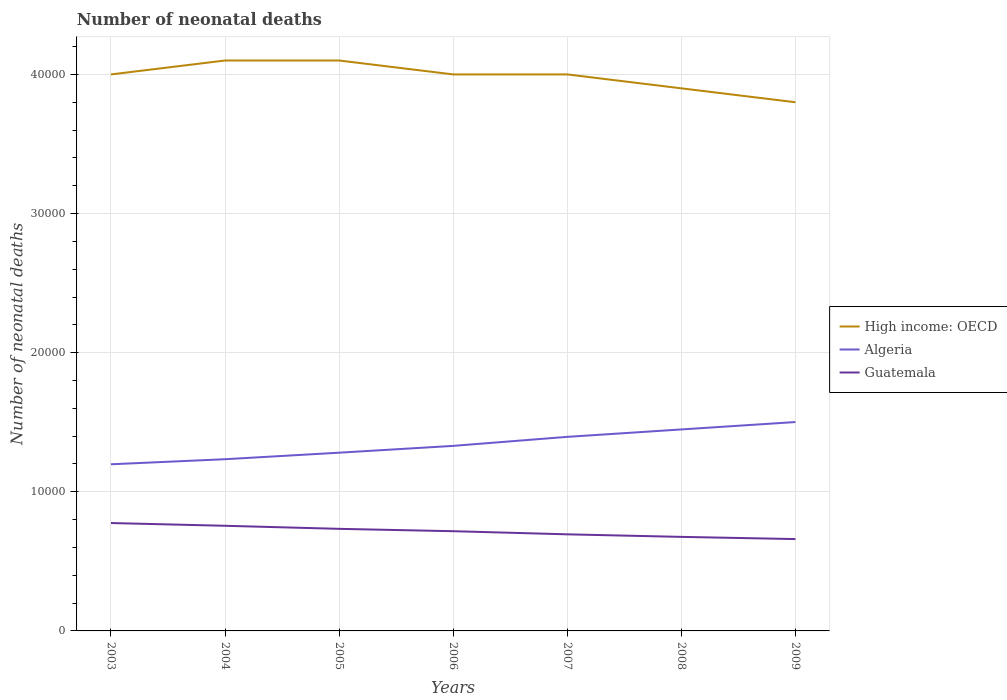How many different coloured lines are there?
Provide a succinct answer. 3. Does the line corresponding to Guatemala intersect with the line corresponding to Algeria?
Provide a short and direct response. No. Across all years, what is the maximum number of neonatal deaths in in High income: OECD?
Your answer should be very brief. 3.80e+04. What is the total number of neonatal deaths in in Algeria in the graph?
Your response must be concise. -1138. What is the difference between the highest and the second highest number of neonatal deaths in in Algeria?
Give a very brief answer. 3035. What is the difference between two consecutive major ticks on the Y-axis?
Your answer should be very brief. 10000. Are the values on the major ticks of Y-axis written in scientific E-notation?
Keep it short and to the point. No. Does the graph contain any zero values?
Provide a succinct answer. No. How many legend labels are there?
Your answer should be very brief. 3. How are the legend labels stacked?
Make the answer very short. Vertical. What is the title of the graph?
Your response must be concise. Number of neonatal deaths. Does "Mozambique" appear as one of the legend labels in the graph?
Offer a terse response. No. What is the label or title of the X-axis?
Offer a very short reply. Years. What is the label or title of the Y-axis?
Keep it short and to the point. Number of neonatal deaths. What is the Number of neonatal deaths in High income: OECD in 2003?
Your answer should be compact. 4.00e+04. What is the Number of neonatal deaths of Algeria in 2003?
Offer a very short reply. 1.20e+04. What is the Number of neonatal deaths of Guatemala in 2003?
Provide a short and direct response. 7755. What is the Number of neonatal deaths of High income: OECD in 2004?
Offer a terse response. 4.10e+04. What is the Number of neonatal deaths in Algeria in 2004?
Offer a terse response. 1.23e+04. What is the Number of neonatal deaths of Guatemala in 2004?
Provide a short and direct response. 7557. What is the Number of neonatal deaths of High income: OECD in 2005?
Provide a succinct answer. 4.10e+04. What is the Number of neonatal deaths of Algeria in 2005?
Your answer should be very brief. 1.28e+04. What is the Number of neonatal deaths of Guatemala in 2005?
Your response must be concise. 7337. What is the Number of neonatal deaths in Algeria in 2006?
Provide a short and direct response. 1.33e+04. What is the Number of neonatal deaths of Guatemala in 2006?
Keep it short and to the point. 7168. What is the Number of neonatal deaths of High income: OECD in 2007?
Your response must be concise. 4.00e+04. What is the Number of neonatal deaths of Algeria in 2007?
Your answer should be very brief. 1.39e+04. What is the Number of neonatal deaths of Guatemala in 2007?
Keep it short and to the point. 6943. What is the Number of neonatal deaths in High income: OECD in 2008?
Provide a short and direct response. 3.90e+04. What is the Number of neonatal deaths in Algeria in 2008?
Ensure brevity in your answer.  1.45e+04. What is the Number of neonatal deaths in Guatemala in 2008?
Your answer should be compact. 6760. What is the Number of neonatal deaths of High income: OECD in 2009?
Offer a very short reply. 3.80e+04. What is the Number of neonatal deaths of Algeria in 2009?
Provide a short and direct response. 1.50e+04. What is the Number of neonatal deaths in Guatemala in 2009?
Your response must be concise. 6601. Across all years, what is the maximum Number of neonatal deaths of High income: OECD?
Your response must be concise. 4.10e+04. Across all years, what is the maximum Number of neonatal deaths in Algeria?
Ensure brevity in your answer.  1.50e+04. Across all years, what is the maximum Number of neonatal deaths of Guatemala?
Make the answer very short. 7755. Across all years, what is the minimum Number of neonatal deaths in High income: OECD?
Your answer should be compact. 3.80e+04. Across all years, what is the minimum Number of neonatal deaths of Algeria?
Make the answer very short. 1.20e+04. Across all years, what is the minimum Number of neonatal deaths in Guatemala?
Provide a short and direct response. 6601. What is the total Number of neonatal deaths in High income: OECD in the graph?
Offer a terse response. 2.79e+05. What is the total Number of neonatal deaths of Algeria in the graph?
Provide a short and direct response. 9.39e+04. What is the total Number of neonatal deaths in Guatemala in the graph?
Provide a succinct answer. 5.01e+04. What is the difference between the Number of neonatal deaths in High income: OECD in 2003 and that in 2004?
Offer a very short reply. -1000. What is the difference between the Number of neonatal deaths in Algeria in 2003 and that in 2004?
Provide a succinct answer. -364. What is the difference between the Number of neonatal deaths of Guatemala in 2003 and that in 2004?
Your answer should be very brief. 198. What is the difference between the Number of neonatal deaths of High income: OECD in 2003 and that in 2005?
Make the answer very short. -1000. What is the difference between the Number of neonatal deaths of Algeria in 2003 and that in 2005?
Your answer should be compact. -833. What is the difference between the Number of neonatal deaths of Guatemala in 2003 and that in 2005?
Ensure brevity in your answer.  418. What is the difference between the Number of neonatal deaths in Algeria in 2003 and that in 2006?
Give a very brief answer. -1323. What is the difference between the Number of neonatal deaths in Guatemala in 2003 and that in 2006?
Keep it short and to the point. 587. What is the difference between the Number of neonatal deaths of High income: OECD in 2003 and that in 2007?
Give a very brief answer. 0. What is the difference between the Number of neonatal deaths in Algeria in 2003 and that in 2007?
Ensure brevity in your answer.  -1971. What is the difference between the Number of neonatal deaths in Guatemala in 2003 and that in 2007?
Provide a short and direct response. 812. What is the difference between the Number of neonatal deaths of High income: OECD in 2003 and that in 2008?
Provide a succinct answer. 1000. What is the difference between the Number of neonatal deaths of Algeria in 2003 and that in 2008?
Offer a terse response. -2504. What is the difference between the Number of neonatal deaths in Guatemala in 2003 and that in 2008?
Your answer should be compact. 995. What is the difference between the Number of neonatal deaths in Algeria in 2003 and that in 2009?
Ensure brevity in your answer.  -3035. What is the difference between the Number of neonatal deaths of Guatemala in 2003 and that in 2009?
Keep it short and to the point. 1154. What is the difference between the Number of neonatal deaths of High income: OECD in 2004 and that in 2005?
Your answer should be compact. 0. What is the difference between the Number of neonatal deaths in Algeria in 2004 and that in 2005?
Offer a terse response. -469. What is the difference between the Number of neonatal deaths of Guatemala in 2004 and that in 2005?
Your answer should be very brief. 220. What is the difference between the Number of neonatal deaths of High income: OECD in 2004 and that in 2006?
Your answer should be very brief. 1000. What is the difference between the Number of neonatal deaths of Algeria in 2004 and that in 2006?
Give a very brief answer. -959. What is the difference between the Number of neonatal deaths in Guatemala in 2004 and that in 2006?
Your response must be concise. 389. What is the difference between the Number of neonatal deaths of Algeria in 2004 and that in 2007?
Give a very brief answer. -1607. What is the difference between the Number of neonatal deaths in Guatemala in 2004 and that in 2007?
Your answer should be compact. 614. What is the difference between the Number of neonatal deaths of Algeria in 2004 and that in 2008?
Make the answer very short. -2140. What is the difference between the Number of neonatal deaths of Guatemala in 2004 and that in 2008?
Provide a succinct answer. 797. What is the difference between the Number of neonatal deaths in High income: OECD in 2004 and that in 2009?
Your response must be concise. 3000. What is the difference between the Number of neonatal deaths in Algeria in 2004 and that in 2009?
Provide a succinct answer. -2671. What is the difference between the Number of neonatal deaths in Guatemala in 2004 and that in 2009?
Provide a succinct answer. 956. What is the difference between the Number of neonatal deaths in Algeria in 2005 and that in 2006?
Ensure brevity in your answer.  -490. What is the difference between the Number of neonatal deaths of Guatemala in 2005 and that in 2006?
Give a very brief answer. 169. What is the difference between the Number of neonatal deaths of High income: OECD in 2005 and that in 2007?
Offer a very short reply. 1000. What is the difference between the Number of neonatal deaths of Algeria in 2005 and that in 2007?
Make the answer very short. -1138. What is the difference between the Number of neonatal deaths in Guatemala in 2005 and that in 2007?
Keep it short and to the point. 394. What is the difference between the Number of neonatal deaths of Algeria in 2005 and that in 2008?
Offer a very short reply. -1671. What is the difference between the Number of neonatal deaths in Guatemala in 2005 and that in 2008?
Your response must be concise. 577. What is the difference between the Number of neonatal deaths in High income: OECD in 2005 and that in 2009?
Keep it short and to the point. 3000. What is the difference between the Number of neonatal deaths in Algeria in 2005 and that in 2009?
Your answer should be very brief. -2202. What is the difference between the Number of neonatal deaths of Guatemala in 2005 and that in 2009?
Your answer should be compact. 736. What is the difference between the Number of neonatal deaths of High income: OECD in 2006 and that in 2007?
Ensure brevity in your answer.  0. What is the difference between the Number of neonatal deaths in Algeria in 2006 and that in 2007?
Make the answer very short. -648. What is the difference between the Number of neonatal deaths in Guatemala in 2006 and that in 2007?
Ensure brevity in your answer.  225. What is the difference between the Number of neonatal deaths of High income: OECD in 2006 and that in 2008?
Your answer should be compact. 1000. What is the difference between the Number of neonatal deaths in Algeria in 2006 and that in 2008?
Your response must be concise. -1181. What is the difference between the Number of neonatal deaths of Guatemala in 2006 and that in 2008?
Your answer should be very brief. 408. What is the difference between the Number of neonatal deaths of High income: OECD in 2006 and that in 2009?
Provide a succinct answer. 2000. What is the difference between the Number of neonatal deaths of Algeria in 2006 and that in 2009?
Give a very brief answer. -1712. What is the difference between the Number of neonatal deaths of Guatemala in 2006 and that in 2009?
Your answer should be compact. 567. What is the difference between the Number of neonatal deaths of High income: OECD in 2007 and that in 2008?
Keep it short and to the point. 1000. What is the difference between the Number of neonatal deaths in Algeria in 2007 and that in 2008?
Your response must be concise. -533. What is the difference between the Number of neonatal deaths of Guatemala in 2007 and that in 2008?
Your answer should be compact. 183. What is the difference between the Number of neonatal deaths in Algeria in 2007 and that in 2009?
Offer a very short reply. -1064. What is the difference between the Number of neonatal deaths of Guatemala in 2007 and that in 2009?
Provide a short and direct response. 342. What is the difference between the Number of neonatal deaths in Algeria in 2008 and that in 2009?
Provide a succinct answer. -531. What is the difference between the Number of neonatal deaths in Guatemala in 2008 and that in 2009?
Provide a short and direct response. 159. What is the difference between the Number of neonatal deaths in High income: OECD in 2003 and the Number of neonatal deaths in Algeria in 2004?
Give a very brief answer. 2.77e+04. What is the difference between the Number of neonatal deaths in High income: OECD in 2003 and the Number of neonatal deaths in Guatemala in 2004?
Give a very brief answer. 3.24e+04. What is the difference between the Number of neonatal deaths of Algeria in 2003 and the Number of neonatal deaths of Guatemala in 2004?
Your answer should be very brief. 4421. What is the difference between the Number of neonatal deaths in High income: OECD in 2003 and the Number of neonatal deaths in Algeria in 2005?
Your response must be concise. 2.72e+04. What is the difference between the Number of neonatal deaths of High income: OECD in 2003 and the Number of neonatal deaths of Guatemala in 2005?
Your response must be concise. 3.27e+04. What is the difference between the Number of neonatal deaths of Algeria in 2003 and the Number of neonatal deaths of Guatemala in 2005?
Your answer should be compact. 4641. What is the difference between the Number of neonatal deaths in High income: OECD in 2003 and the Number of neonatal deaths in Algeria in 2006?
Offer a terse response. 2.67e+04. What is the difference between the Number of neonatal deaths in High income: OECD in 2003 and the Number of neonatal deaths in Guatemala in 2006?
Make the answer very short. 3.28e+04. What is the difference between the Number of neonatal deaths in Algeria in 2003 and the Number of neonatal deaths in Guatemala in 2006?
Keep it short and to the point. 4810. What is the difference between the Number of neonatal deaths in High income: OECD in 2003 and the Number of neonatal deaths in Algeria in 2007?
Provide a short and direct response. 2.61e+04. What is the difference between the Number of neonatal deaths in High income: OECD in 2003 and the Number of neonatal deaths in Guatemala in 2007?
Keep it short and to the point. 3.31e+04. What is the difference between the Number of neonatal deaths of Algeria in 2003 and the Number of neonatal deaths of Guatemala in 2007?
Your answer should be very brief. 5035. What is the difference between the Number of neonatal deaths of High income: OECD in 2003 and the Number of neonatal deaths of Algeria in 2008?
Offer a very short reply. 2.55e+04. What is the difference between the Number of neonatal deaths of High income: OECD in 2003 and the Number of neonatal deaths of Guatemala in 2008?
Your answer should be compact. 3.32e+04. What is the difference between the Number of neonatal deaths of Algeria in 2003 and the Number of neonatal deaths of Guatemala in 2008?
Offer a very short reply. 5218. What is the difference between the Number of neonatal deaths of High income: OECD in 2003 and the Number of neonatal deaths of Algeria in 2009?
Your answer should be compact. 2.50e+04. What is the difference between the Number of neonatal deaths of High income: OECD in 2003 and the Number of neonatal deaths of Guatemala in 2009?
Offer a terse response. 3.34e+04. What is the difference between the Number of neonatal deaths of Algeria in 2003 and the Number of neonatal deaths of Guatemala in 2009?
Ensure brevity in your answer.  5377. What is the difference between the Number of neonatal deaths of High income: OECD in 2004 and the Number of neonatal deaths of Algeria in 2005?
Ensure brevity in your answer.  2.82e+04. What is the difference between the Number of neonatal deaths of High income: OECD in 2004 and the Number of neonatal deaths of Guatemala in 2005?
Offer a terse response. 3.37e+04. What is the difference between the Number of neonatal deaths of Algeria in 2004 and the Number of neonatal deaths of Guatemala in 2005?
Provide a succinct answer. 5005. What is the difference between the Number of neonatal deaths of High income: OECD in 2004 and the Number of neonatal deaths of Algeria in 2006?
Give a very brief answer. 2.77e+04. What is the difference between the Number of neonatal deaths in High income: OECD in 2004 and the Number of neonatal deaths in Guatemala in 2006?
Your answer should be compact. 3.38e+04. What is the difference between the Number of neonatal deaths in Algeria in 2004 and the Number of neonatal deaths in Guatemala in 2006?
Ensure brevity in your answer.  5174. What is the difference between the Number of neonatal deaths in High income: OECD in 2004 and the Number of neonatal deaths in Algeria in 2007?
Your response must be concise. 2.71e+04. What is the difference between the Number of neonatal deaths in High income: OECD in 2004 and the Number of neonatal deaths in Guatemala in 2007?
Ensure brevity in your answer.  3.41e+04. What is the difference between the Number of neonatal deaths of Algeria in 2004 and the Number of neonatal deaths of Guatemala in 2007?
Ensure brevity in your answer.  5399. What is the difference between the Number of neonatal deaths of High income: OECD in 2004 and the Number of neonatal deaths of Algeria in 2008?
Your answer should be compact. 2.65e+04. What is the difference between the Number of neonatal deaths of High income: OECD in 2004 and the Number of neonatal deaths of Guatemala in 2008?
Give a very brief answer. 3.42e+04. What is the difference between the Number of neonatal deaths of Algeria in 2004 and the Number of neonatal deaths of Guatemala in 2008?
Your answer should be compact. 5582. What is the difference between the Number of neonatal deaths in High income: OECD in 2004 and the Number of neonatal deaths in Algeria in 2009?
Ensure brevity in your answer.  2.60e+04. What is the difference between the Number of neonatal deaths of High income: OECD in 2004 and the Number of neonatal deaths of Guatemala in 2009?
Offer a terse response. 3.44e+04. What is the difference between the Number of neonatal deaths of Algeria in 2004 and the Number of neonatal deaths of Guatemala in 2009?
Ensure brevity in your answer.  5741. What is the difference between the Number of neonatal deaths in High income: OECD in 2005 and the Number of neonatal deaths in Algeria in 2006?
Your response must be concise. 2.77e+04. What is the difference between the Number of neonatal deaths in High income: OECD in 2005 and the Number of neonatal deaths in Guatemala in 2006?
Make the answer very short. 3.38e+04. What is the difference between the Number of neonatal deaths of Algeria in 2005 and the Number of neonatal deaths of Guatemala in 2006?
Your response must be concise. 5643. What is the difference between the Number of neonatal deaths of High income: OECD in 2005 and the Number of neonatal deaths of Algeria in 2007?
Your answer should be very brief. 2.71e+04. What is the difference between the Number of neonatal deaths in High income: OECD in 2005 and the Number of neonatal deaths in Guatemala in 2007?
Your response must be concise. 3.41e+04. What is the difference between the Number of neonatal deaths in Algeria in 2005 and the Number of neonatal deaths in Guatemala in 2007?
Make the answer very short. 5868. What is the difference between the Number of neonatal deaths of High income: OECD in 2005 and the Number of neonatal deaths of Algeria in 2008?
Make the answer very short. 2.65e+04. What is the difference between the Number of neonatal deaths in High income: OECD in 2005 and the Number of neonatal deaths in Guatemala in 2008?
Keep it short and to the point. 3.42e+04. What is the difference between the Number of neonatal deaths of Algeria in 2005 and the Number of neonatal deaths of Guatemala in 2008?
Your answer should be compact. 6051. What is the difference between the Number of neonatal deaths of High income: OECD in 2005 and the Number of neonatal deaths of Algeria in 2009?
Ensure brevity in your answer.  2.60e+04. What is the difference between the Number of neonatal deaths of High income: OECD in 2005 and the Number of neonatal deaths of Guatemala in 2009?
Ensure brevity in your answer.  3.44e+04. What is the difference between the Number of neonatal deaths in Algeria in 2005 and the Number of neonatal deaths in Guatemala in 2009?
Ensure brevity in your answer.  6210. What is the difference between the Number of neonatal deaths of High income: OECD in 2006 and the Number of neonatal deaths of Algeria in 2007?
Offer a terse response. 2.61e+04. What is the difference between the Number of neonatal deaths of High income: OECD in 2006 and the Number of neonatal deaths of Guatemala in 2007?
Make the answer very short. 3.31e+04. What is the difference between the Number of neonatal deaths in Algeria in 2006 and the Number of neonatal deaths in Guatemala in 2007?
Provide a succinct answer. 6358. What is the difference between the Number of neonatal deaths in High income: OECD in 2006 and the Number of neonatal deaths in Algeria in 2008?
Offer a terse response. 2.55e+04. What is the difference between the Number of neonatal deaths of High income: OECD in 2006 and the Number of neonatal deaths of Guatemala in 2008?
Make the answer very short. 3.32e+04. What is the difference between the Number of neonatal deaths of Algeria in 2006 and the Number of neonatal deaths of Guatemala in 2008?
Give a very brief answer. 6541. What is the difference between the Number of neonatal deaths of High income: OECD in 2006 and the Number of neonatal deaths of Algeria in 2009?
Offer a very short reply. 2.50e+04. What is the difference between the Number of neonatal deaths in High income: OECD in 2006 and the Number of neonatal deaths in Guatemala in 2009?
Give a very brief answer. 3.34e+04. What is the difference between the Number of neonatal deaths in Algeria in 2006 and the Number of neonatal deaths in Guatemala in 2009?
Give a very brief answer. 6700. What is the difference between the Number of neonatal deaths of High income: OECD in 2007 and the Number of neonatal deaths of Algeria in 2008?
Provide a short and direct response. 2.55e+04. What is the difference between the Number of neonatal deaths of High income: OECD in 2007 and the Number of neonatal deaths of Guatemala in 2008?
Offer a terse response. 3.32e+04. What is the difference between the Number of neonatal deaths in Algeria in 2007 and the Number of neonatal deaths in Guatemala in 2008?
Your answer should be very brief. 7189. What is the difference between the Number of neonatal deaths of High income: OECD in 2007 and the Number of neonatal deaths of Algeria in 2009?
Your answer should be compact. 2.50e+04. What is the difference between the Number of neonatal deaths in High income: OECD in 2007 and the Number of neonatal deaths in Guatemala in 2009?
Give a very brief answer. 3.34e+04. What is the difference between the Number of neonatal deaths of Algeria in 2007 and the Number of neonatal deaths of Guatemala in 2009?
Provide a short and direct response. 7348. What is the difference between the Number of neonatal deaths in High income: OECD in 2008 and the Number of neonatal deaths in Algeria in 2009?
Offer a very short reply. 2.40e+04. What is the difference between the Number of neonatal deaths in High income: OECD in 2008 and the Number of neonatal deaths in Guatemala in 2009?
Keep it short and to the point. 3.24e+04. What is the difference between the Number of neonatal deaths in Algeria in 2008 and the Number of neonatal deaths in Guatemala in 2009?
Your response must be concise. 7881. What is the average Number of neonatal deaths of High income: OECD per year?
Your response must be concise. 3.99e+04. What is the average Number of neonatal deaths in Algeria per year?
Provide a short and direct response. 1.34e+04. What is the average Number of neonatal deaths of Guatemala per year?
Your answer should be very brief. 7160.14. In the year 2003, what is the difference between the Number of neonatal deaths in High income: OECD and Number of neonatal deaths in Algeria?
Keep it short and to the point. 2.80e+04. In the year 2003, what is the difference between the Number of neonatal deaths of High income: OECD and Number of neonatal deaths of Guatemala?
Make the answer very short. 3.22e+04. In the year 2003, what is the difference between the Number of neonatal deaths in Algeria and Number of neonatal deaths in Guatemala?
Provide a succinct answer. 4223. In the year 2004, what is the difference between the Number of neonatal deaths of High income: OECD and Number of neonatal deaths of Algeria?
Your response must be concise. 2.87e+04. In the year 2004, what is the difference between the Number of neonatal deaths in High income: OECD and Number of neonatal deaths in Guatemala?
Your response must be concise. 3.34e+04. In the year 2004, what is the difference between the Number of neonatal deaths of Algeria and Number of neonatal deaths of Guatemala?
Your response must be concise. 4785. In the year 2005, what is the difference between the Number of neonatal deaths of High income: OECD and Number of neonatal deaths of Algeria?
Your response must be concise. 2.82e+04. In the year 2005, what is the difference between the Number of neonatal deaths in High income: OECD and Number of neonatal deaths in Guatemala?
Your answer should be very brief. 3.37e+04. In the year 2005, what is the difference between the Number of neonatal deaths in Algeria and Number of neonatal deaths in Guatemala?
Give a very brief answer. 5474. In the year 2006, what is the difference between the Number of neonatal deaths in High income: OECD and Number of neonatal deaths in Algeria?
Your answer should be compact. 2.67e+04. In the year 2006, what is the difference between the Number of neonatal deaths of High income: OECD and Number of neonatal deaths of Guatemala?
Your answer should be very brief. 3.28e+04. In the year 2006, what is the difference between the Number of neonatal deaths of Algeria and Number of neonatal deaths of Guatemala?
Ensure brevity in your answer.  6133. In the year 2007, what is the difference between the Number of neonatal deaths in High income: OECD and Number of neonatal deaths in Algeria?
Your answer should be compact. 2.61e+04. In the year 2007, what is the difference between the Number of neonatal deaths of High income: OECD and Number of neonatal deaths of Guatemala?
Your answer should be compact. 3.31e+04. In the year 2007, what is the difference between the Number of neonatal deaths in Algeria and Number of neonatal deaths in Guatemala?
Give a very brief answer. 7006. In the year 2008, what is the difference between the Number of neonatal deaths of High income: OECD and Number of neonatal deaths of Algeria?
Offer a terse response. 2.45e+04. In the year 2008, what is the difference between the Number of neonatal deaths of High income: OECD and Number of neonatal deaths of Guatemala?
Ensure brevity in your answer.  3.22e+04. In the year 2008, what is the difference between the Number of neonatal deaths in Algeria and Number of neonatal deaths in Guatemala?
Your response must be concise. 7722. In the year 2009, what is the difference between the Number of neonatal deaths of High income: OECD and Number of neonatal deaths of Algeria?
Give a very brief answer. 2.30e+04. In the year 2009, what is the difference between the Number of neonatal deaths of High income: OECD and Number of neonatal deaths of Guatemala?
Your response must be concise. 3.14e+04. In the year 2009, what is the difference between the Number of neonatal deaths in Algeria and Number of neonatal deaths in Guatemala?
Give a very brief answer. 8412. What is the ratio of the Number of neonatal deaths in High income: OECD in 2003 to that in 2004?
Offer a terse response. 0.98. What is the ratio of the Number of neonatal deaths of Algeria in 2003 to that in 2004?
Keep it short and to the point. 0.97. What is the ratio of the Number of neonatal deaths of Guatemala in 2003 to that in 2004?
Provide a short and direct response. 1.03. What is the ratio of the Number of neonatal deaths of High income: OECD in 2003 to that in 2005?
Make the answer very short. 0.98. What is the ratio of the Number of neonatal deaths in Algeria in 2003 to that in 2005?
Provide a succinct answer. 0.94. What is the ratio of the Number of neonatal deaths of Guatemala in 2003 to that in 2005?
Keep it short and to the point. 1.06. What is the ratio of the Number of neonatal deaths in High income: OECD in 2003 to that in 2006?
Offer a very short reply. 1. What is the ratio of the Number of neonatal deaths of Algeria in 2003 to that in 2006?
Offer a terse response. 0.9. What is the ratio of the Number of neonatal deaths of Guatemala in 2003 to that in 2006?
Offer a very short reply. 1.08. What is the ratio of the Number of neonatal deaths of Algeria in 2003 to that in 2007?
Offer a very short reply. 0.86. What is the ratio of the Number of neonatal deaths in Guatemala in 2003 to that in 2007?
Your response must be concise. 1.12. What is the ratio of the Number of neonatal deaths of High income: OECD in 2003 to that in 2008?
Make the answer very short. 1.03. What is the ratio of the Number of neonatal deaths in Algeria in 2003 to that in 2008?
Offer a terse response. 0.83. What is the ratio of the Number of neonatal deaths of Guatemala in 2003 to that in 2008?
Provide a short and direct response. 1.15. What is the ratio of the Number of neonatal deaths of High income: OECD in 2003 to that in 2009?
Your response must be concise. 1.05. What is the ratio of the Number of neonatal deaths in Algeria in 2003 to that in 2009?
Provide a short and direct response. 0.8. What is the ratio of the Number of neonatal deaths in Guatemala in 2003 to that in 2009?
Ensure brevity in your answer.  1.17. What is the ratio of the Number of neonatal deaths in Algeria in 2004 to that in 2005?
Provide a succinct answer. 0.96. What is the ratio of the Number of neonatal deaths of High income: OECD in 2004 to that in 2006?
Ensure brevity in your answer.  1.02. What is the ratio of the Number of neonatal deaths of Algeria in 2004 to that in 2006?
Offer a terse response. 0.93. What is the ratio of the Number of neonatal deaths of Guatemala in 2004 to that in 2006?
Provide a succinct answer. 1.05. What is the ratio of the Number of neonatal deaths in High income: OECD in 2004 to that in 2007?
Offer a terse response. 1.02. What is the ratio of the Number of neonatal deaths in Algeria in 2004 to that in 2007?
Offer a terse response. 0.88. What is the ratio of the Number of neonatal deaths of Guatemala in 2004 to that in 2007?
Ensure brevity in your answer.  1.09. What is the ratio of the Number of neonatal deaths of High income: OECD in 2004 to that in 2008?
Your response must be concise. 1.05. What is the ratio of the Number of neonatal deaths in Algeria in 2004 to that in 2008?
Your answer should be very brief. 0.85. What is the ratio of the Number of neonatal deaths in Guatemala in 2004 to that in 2008?
Keep it short and to the point. 1.12. What is the ratio of the Number of neonatal deaths in High income: OECD in 2004 to that in 2009?
Provide a short and direct response. 1.08. What is the ratio of the Number of neonatal deaths of Algeria in 2004 to that in 2009?
Provide a succinct answer. 0.82. What is the ratio of the Number of neonatal deaths of Guatemala in 2004 to that in 2009?
Provide a short and direct response. 1.14. What is the ratio of the Number of neonatal deaths of Algeria in 2005 to that in 2006?
Your answer should be very brief. 0.96. What is the ratio of the Number of neonatal deaths of Guatemala in 2005 to that in 2006?
Your response must be concise. 1.02. What is the ratio of the Number of neonatal deaths in Algeria in 2005 to that in 2007?
Keep it short and to the point. 0.92. What is the ratio of the Number of neonatal deaths in Guatemala in 2005 to that in 2007?
Offer a very short reply. 1.06. What is the ratio of the Number of neonatal deaths of High income: OECD in 2005 to that in 2008?
Offer a very short reply. 1.05. What is the ratio of the Number of neonatal deaths in Algeria in 2005 to that in 2008?
Keep it short and to the point. 0.88. What is the ratio of the Number of neonatal deaths in Guatemala in 2005 to that in 2008?
Make the answer very short. 1.09. What is the ratio of the Number of neonatal deaths in High income: OECD in 2005 to that in 2009?
Your answer should be very brief. 1.08. What is the ratio of the Number of neonatal deaths in Algeria in 2005 to that in 2009?
Your answer should be very brief. 0.85. What is the ratio of the Number of neonatal deaths in Guatemala in 2005 to that in 2009?
Ensure brevity in your answer.  1.11. What is the ratio of the Number of neonatal deaths of High income: OECD in 2006 to that in 2007?
Ensure brevity in your answer.  1. What is the ratio of the Number of neonatal deaths of Algeria in 2006 to that in 2007?
Provide a succinct answer. 0.95. What is the ratio of the Number of neonatal deaths of Guatemala in 2006 to that in 2007?
Provide a short and direct response. 1.03. What is the ratio of the Number of neonatal deaths in High income: OECD in 2006 to that in 2008?
Your answer should be compact. 1.03. What is the ratio of the Number of neonatal deaths of Algeria in 2006 to that in 2008?
Ensure brevity in your answer.  0.92. What is the ratio of the Number of neonatal deaths in Guatemala in 2006 to that in 2008?
Your answer should be very brief. 1.06. What is the ratio of the Number of neonatal deaths in High income: OECD in 2006 to that in 2009?
Offer a terse response. 1.05. What is the ratio of the Number of neonatal deaths in Algeria in 2006 to that in 2009?
Offer a very short reply. 0.89. What is the ratio of the Number of neonatal deaths in Guatemala in 2006 to that in 2009?
Offer a very short reply. 1.09. What is the ratio of the Number of neonatal deaths of High income: OECD in 2007 to that in 2008?
Offer a very short reply. 1.03. What is the ratio of the Number of neonatal deaths of Algeria in 2007 to that in 2008?
Your response must be concise. 0.96. What is the ratio of the Number of neonatal deaths in Guatemala in 2007 to that in 2008?
Offer a very short reply. 1.03. What is the ratio of the Number of neonatal deaths of High income: OECD in 2007 to that in 2009?
Your answer should be very brief. 1.05. What is the ratio of the Number of neonatal deaths in Algeria in 2007 to that in 2009?
Your answer should be compact. 0.93. What is the ratio of the Number of neonatal deaths in Guatemala in 2007 to that in 2009?
Give a very brief answer. 1.05. What is the ratio of the Number of neonatal deaths in High income: OECD in 2008 to that in 2009?
Ensure brevity in your answer.  1.03. What is the ratio of the Number of neonatal deaths in Algeria in 2008 to that in 2009?
Provide a short and direct response. 0.96. What is the ratio of the Number of neonatal deaths in Guatemala in 2008 to that in 2009?
Make the answer very short. 1.02. What is the difference between the highest and the second highest Number of neonatal deaths of Algeria?
Your answer should be compact. 531. What is the difference between the highest and the second highest Number of neonatal deaths of Guatemala?
Ensure brevity in your answer.  198. What is the difference between the highest and the lowest Number of neonatal deaths in High income: OECD?
Provide a succinct answer. 3000. What is the difference between the highest and the lowest Number of neonatal deaths of Algeria?
Ensure brevity in your answer.  3035. What is the difference between the highest and the lowest Number of neonatal deaths in Guatemala?
Your answer should be compact. 1154. 